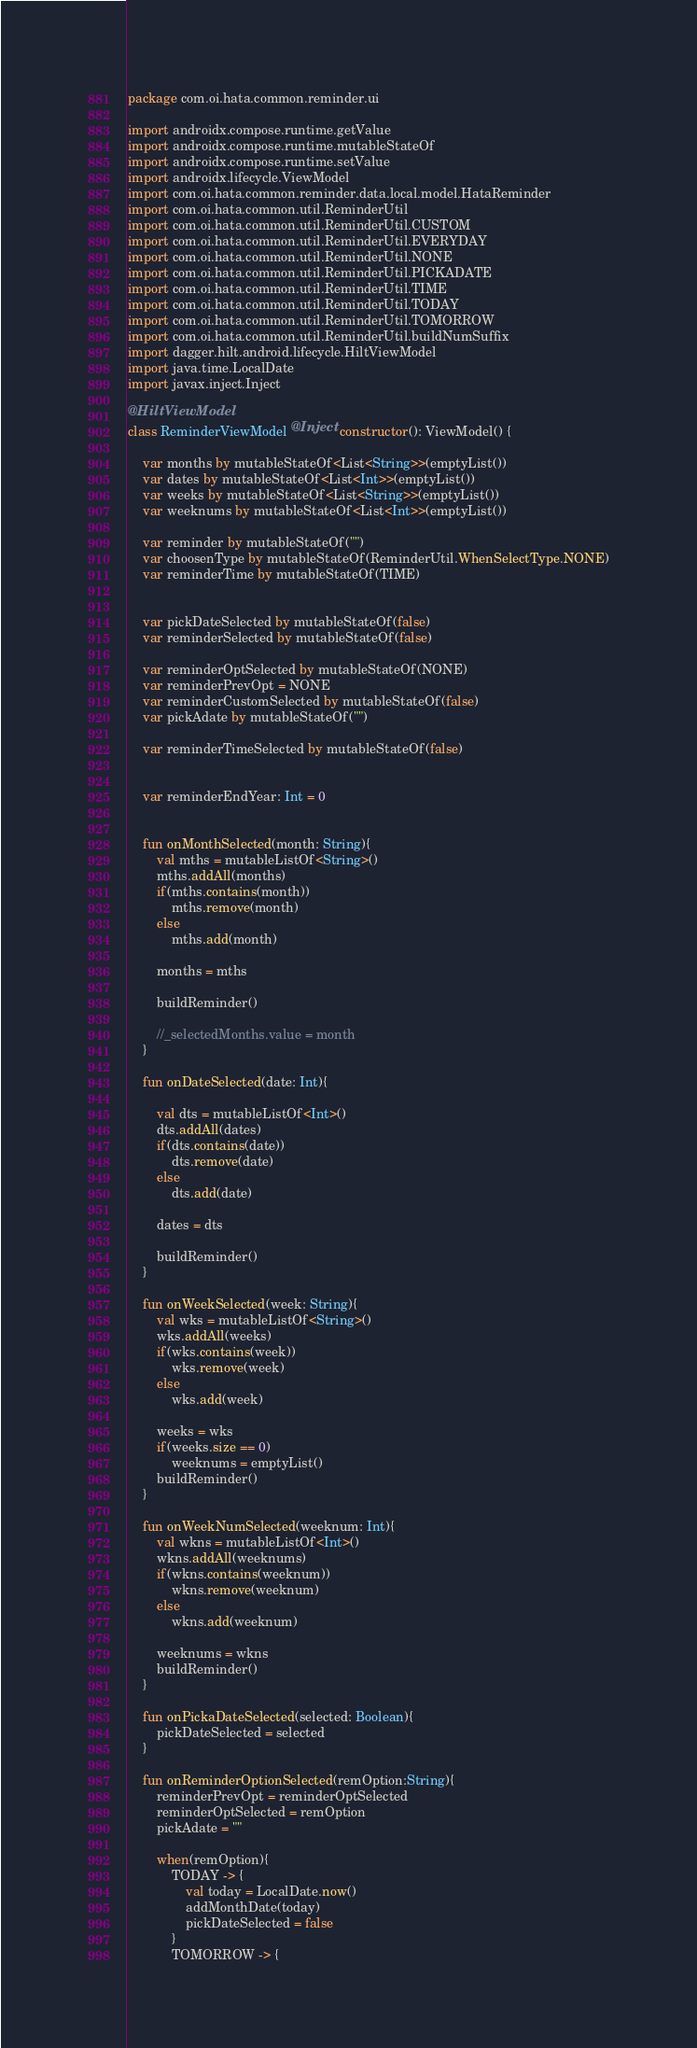Convert code to text. <code><loc_0><loc_0><loc_500><loc_500><_Kotlin_>package com.oi.hata.common.reminder.ui

import androidx.compose.runtime.getValue
import androidx.compose.runtime.mutableStateOf
import androidx.compose.runtime.setValue
import androidx.lifecycle.ViewModel
import com.oi.hata.common.reminder.data.local.model.HataReminder
import com.oi.hata.common.util.ReminderUtil
import com.oi.hata.common.util.ReminderUtil.CUSTOM
import com.oi.hata.common.util.ReminderUtil.EVERYDAY
import com.oi.hata.common.util.ReminderUtil.NONE
import com.oi.hata.common.util.ReminderUtil.PICKADATE
import com.oi.hata.common.util.ReminderUtil.TIME
import com.oi.hata.common.util.ReminderUtil.TODAY
import com.oi.hata.common.util.ReminderUtil.TOMORROW
import com.oi.hata.common.util.ReminderUtil.buildNumSuffix
import dagger.hilt.android.lifecycle.HiltViewModel
import java.time.LocalDate
import javax.inject.Inject

@HiltViewModel
class ReminderViewModel @Inject constructor(): ViewModel() {

    var months by mutableStateOf<List<String>>(emptyList())
    var dates by mutableStateOf<List<Int>>(emptyList())
    var weeks by mutableStateOf<List<String>>(emptyList())
    var weeknums by mutableStateOf<List<Int>>(emptyList())

    var reminder by mutableStateOf("")
    var choosenType by mutableStateOf(ReminderUtil.WhenSelectType.NONE)
    var reminderTime by mutableStateOf(TIME)


    var pickDateSelected by mutableStateOf(false)
    var reminderSelected by mutableStateOf(false)

    var reminderOptSelected by mutableStateOf(NONE)
    var reminderPrevOpt = NONE
    var reminderCustomSelected by mutableStateOf(false)
    var pickAdate by mutableStateOf("")

    var reminderTimeSelected by mutableStateOf(false)


    var reminderEndYear: Int = 0


    fun onMonthSelected(month: String){
        val mths = mutableListOf<String>()
        mths.addAll(months)
        if(mths.contains(month))
            mths.remove(month)
        else
            mths.add(month)

        months = mths

        buildReminder()

        //_selectedMonths.value = month
    }

    fun onDateSelected(date: Int){

        val dts = mutableListOf<Int>()
        dts.addAll(dates)
        if(dts.contains(date))
            dts.remove(date)
        else
            dts.add(date)

        dates = dts

        buildReminder()
    }

    fun onWeekSelected(week: String){
        val wks = mutableListOf<String>()
        wks.addAll(weeks)
        if(wks.contains(week))
            wks.remove(week)
        else
            wks.add(week)

        weeks = wks
        if(weeks.size == 0)
            weeknums = emptyList()
        buildReminder()
    }

    fun onWeekNumSelected(weeknum: Int){
        val wkns = mutableListOf<Int>()
        wkns.addAll(weeknums)
        if(wkns.contains(weeknum))
            wkns.remove(weeknum)
        else
            wkns.add(weeknum)

        weeknums = wkns
        buildReminder()
    }

    fun onPickaDateSelected(selected: Boolean){
        pickDateSelected = selected
    }

    fun onReminderOptionSelected(remOption:String){
        reminderPrevOpt = reminderOptSelected
        reminderOptSelected = remOption
        pickAdate = ""

        when(remOption){
            TODAY -> {
                val today = LocalDate.now()
                addMonthDate(today)
                pickDateSelected = false
            }
            TOMORROW -> {</code> 